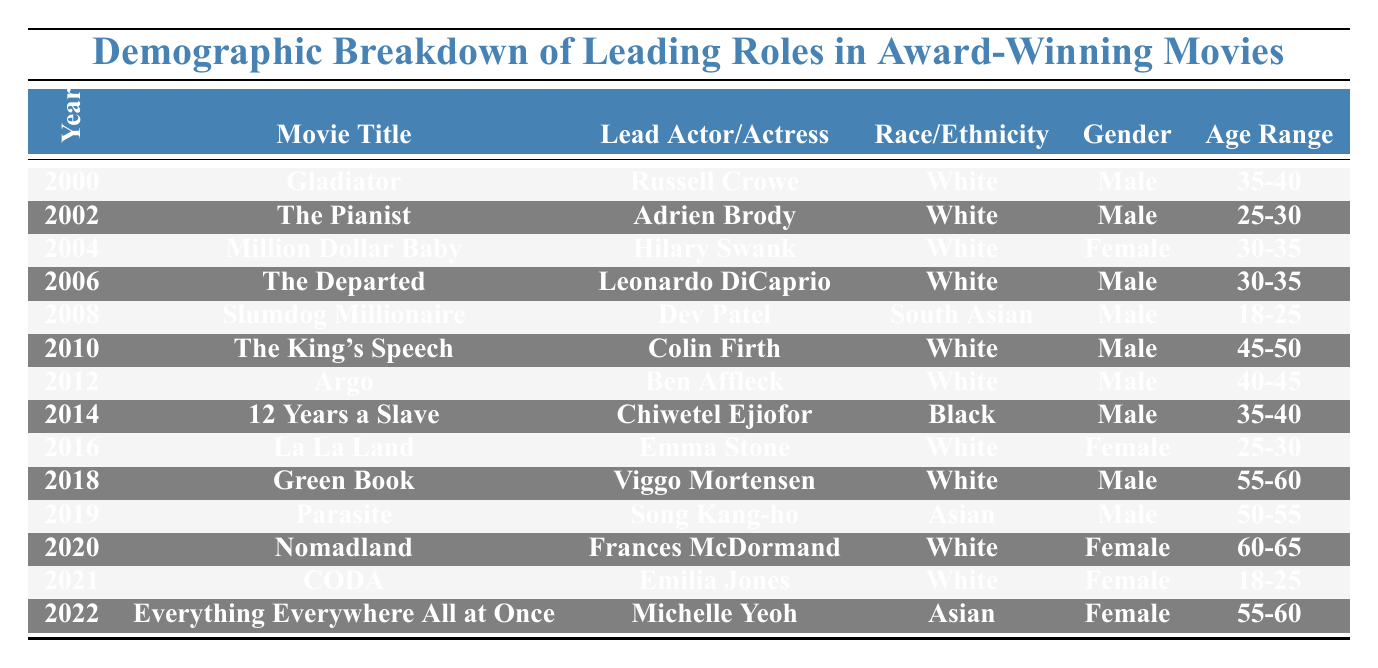What is the title of the movie from 2014? By looking at the "Year" column, I find the entry for 2014, which corresponds to the movie "12 Years a Slave".
Answer: 12 Years a Slave How many lead roles were portrayed by female actors? I will count the rows where the "Gender" column indicates "Female". There are 4 such entries in the table: "Hilary Swank", "Emma Stone", "Frances McDormand", and "Michelle Yeoh".
Answer: 4 Who played the lead role in "Slumdog Millionaire"? Referring to the row with "Slumdog Millionaire" in the "Movie Title" column, the lead role was portrayed by Dev Patel.
Answer: Dev Patel What is the age range of the lead actor in "The King's Speech"? I will check the row for "The King's Speech" in the table; the age range listed is "45-50".
Answer: 45-50 How many movies feature lead actors from the "White" race/ethnicity? To find this, I count the number of occurrences in the "Race/Ethnicity" column that state "White". There are 8 entries that match this criteria.
Answer: 8 In which year did a South Asian lead an award-winning film? Looking through the table, the entry for "Slumdog Millionaire" is the only one with a South Asian lead, which is situated in the year 2008.
Answer: 2008 What is the median age range of lead actors in the movies listed in the table? I identify the age ranges: 18-25, 25-30, 30-35, 35-40, 40-45, 45-50, 50-55, 55-60, and 60-65. I convert these ranges to numbers: (21.5, 27.5, 32.5, 37.5, 42.5, 47.5, 52.5, 57.5, 62.5). With a total of 13 entries, the median will come from the 7th and 8th values: (47.5 + 52.5) / 2 = 50.
Answer: 50 Did any movie between 2000 and 2010 have a lead actor of Asian descent? I check the rows for 2000-2010, and I find "Slumdog Millionaire" with its lead actor Dev Patel matching the Asian descent criteria.
Answer: Yes Which gender appears most frequently as lead roles in the table? Upon counting the entries, "Male" appears in 9 entries while "Female" appears in 4 entries. Thus, "Male" is more frequent.
Answer: Male Which lead actress was the oldest in terms of age range? In the "Age Range" column, the oldest age range associated with a female lead is "60-65", which corresponds to Frances McDormand in "Nomadland".
Answer: Frances McDormand How many unique race/ethnicities are represented in leading roles from the data provided? I will list the distinct race/ethnicities: White, South Asian, Black, and Asian, which gives a total of 4 unique entries.
Answer: 4 